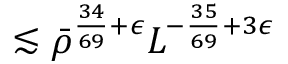<formula> <loc_0><loc_0><loc_500><loc_500>\lesssim \bar { \rho } ^ { \frac { 3 4 } { 6 9 } + \epsilon } L ^ { - \frac { 3 5 } { 6 9 } + 3 \epsilon }</formula> 